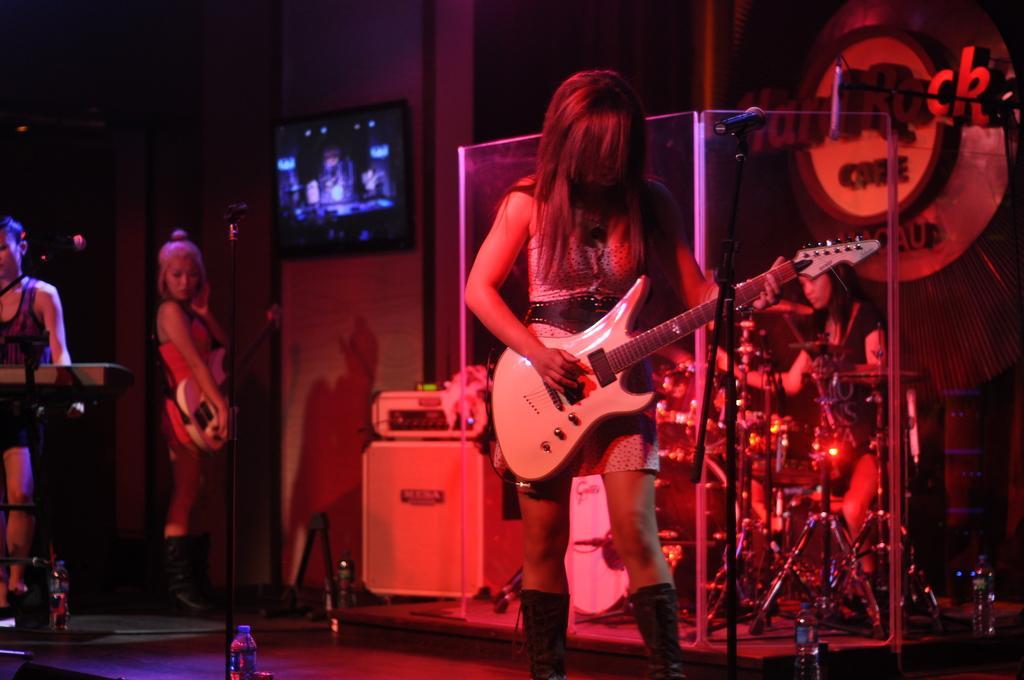Can you describe this image briefly? This image is clicked in a musical concert. There are three people in this image, two of them are three of them are playing musical instruments. Behind them there are drums and there is a woman who is playing drums. There is a TV on the top. 